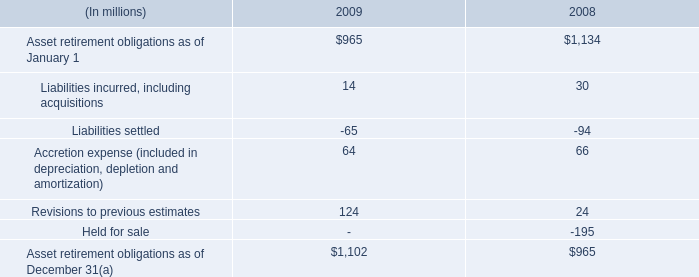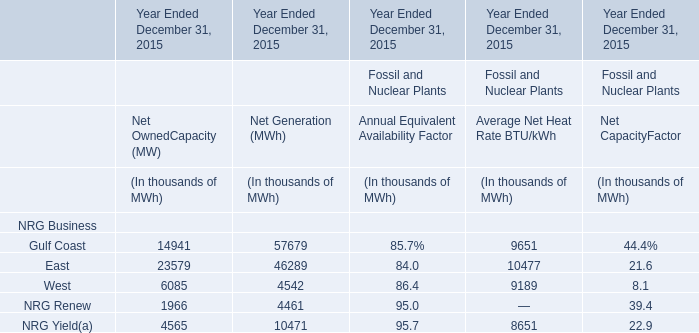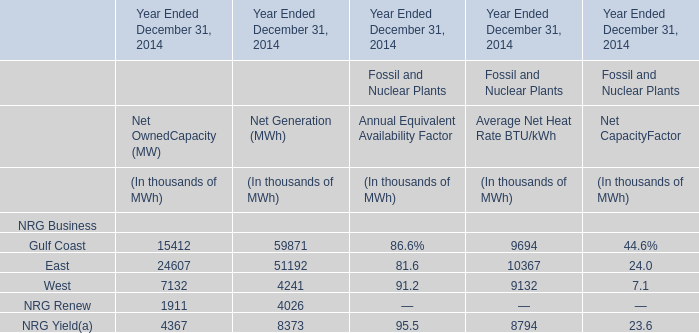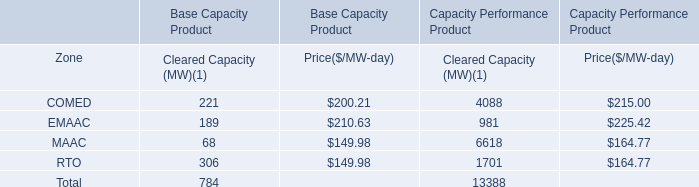Which section is Average Net Heat Rate the highest? (in thousand) 
Answer: East. 